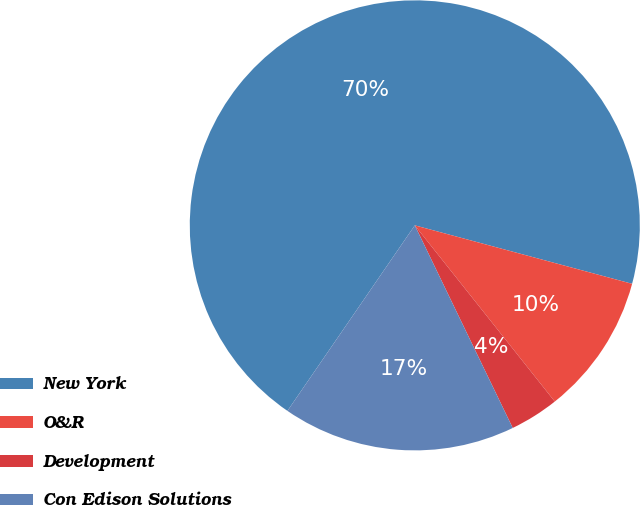<chart> <loc_0><loc_0><loc_500><loc_500><pie_chart><fcel>New York<fcel>O&R<fcel>Development<fcel>Con Edison Solutions<nl><fcel>69.6%<fcel>10.13%<fcel>3.52%<fcel>16.74%<nl></chart> 